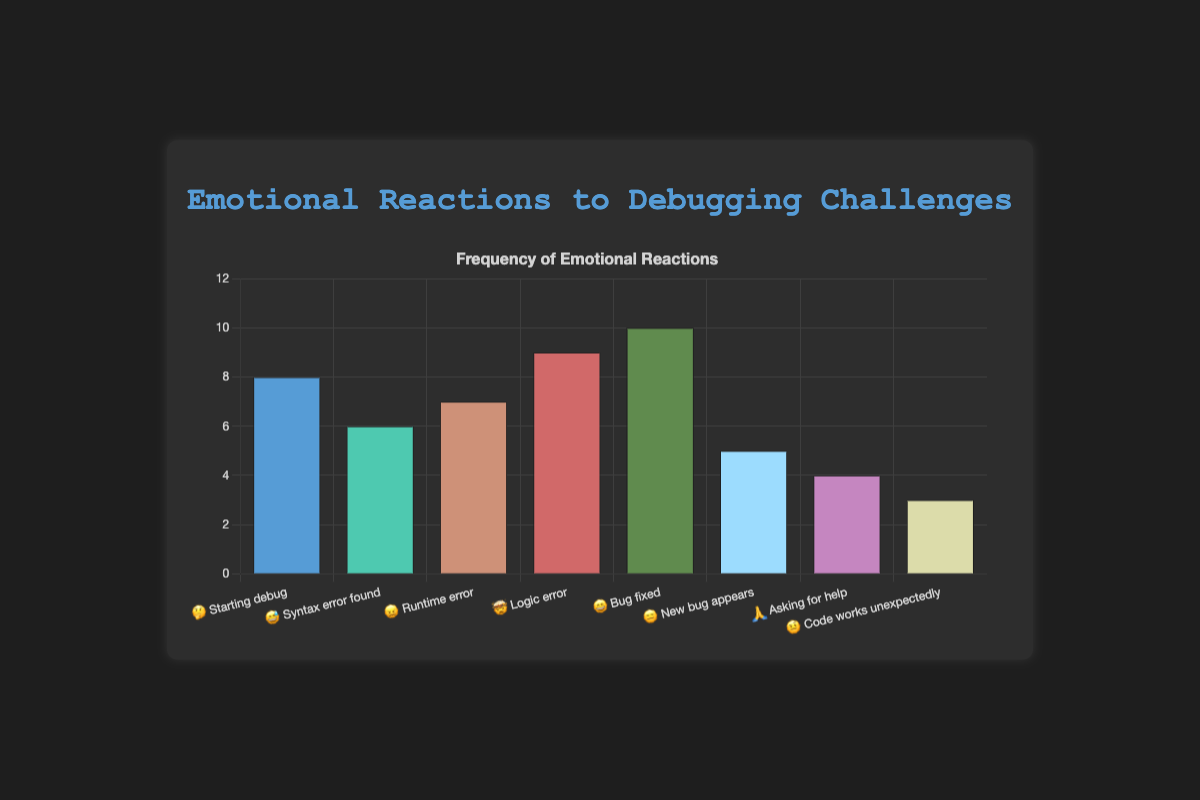Which stage has the highest frequency of emotional reactions? Look for the bar with the greatest height. In this bar chart, "Bug fixed 😄" appears to have the highest value, which is 10.
Answer: Bug fixed 😄 Which stage has the lowest frequency of emotional reactions? Look for the shortest bar in the chart. "Code works unexpectedly 🤨" has the lowest frequency with a value of 3.
Answer: Code works unexpectedly 🤨 What is the total frequency of emotional reactions for "Starting debug 🤔" and "Runtime error 😖"? Sum the frequencies of "Starting debug 🤔" (8) and "Runtime error 😖" (7). The sum is 8 + 7 = 15.
Answer: 15 Are the frequencies of "Syntax error found 😅" and "Runtime error 😖" equal? Compare the frequencies of "Syntax error found 😅" (6) and "Runtime error 😖" (7). They are not equal.
Answer: No Which stage has a greater frequency: "Logic error 🤯" or "New bug appears 😑"? Compare the frequencies of "Logic error 🤯" (9) and "New bug appears 😑" (5). "Logic error 🤯" has a greater frequency.
Answer: Logic error 🤯 Is the frequency of "Asking for help 🙏" less than half of "Bug fixed 😄"? Compare half of "Bug fixed 😄" (10/2 = 5) with the frequency of "Asking for help 🙏" (4). 4 is less than 5.
Answer: Yes How many stages have a frequency greater than 8? Count the bars with frequencies greater than 8. Only "Bug fixed 😄" (10) and "Logic error 🤯" (9) have frequencies greater than 8.
Answer: 2 What is the average frequency of all emotional reactions? Sum all the frequencies and divide by the number of stages. Total frequency: 8 + 6 + 7 + 9 + 10 + 5 + 4 + 3 = 52. Number of stages: 8. Average = 52 / 8 = 6.5.
Answer: 6.5 Which pairs of stages have the same frequency of emotional reactions? Look for bars of equal height. Only "Syntax error found 😅" (6) and "New bug appears 😑" (5) do not match the frequency of any other stages; all other frequencies are unique.
Answer: None 